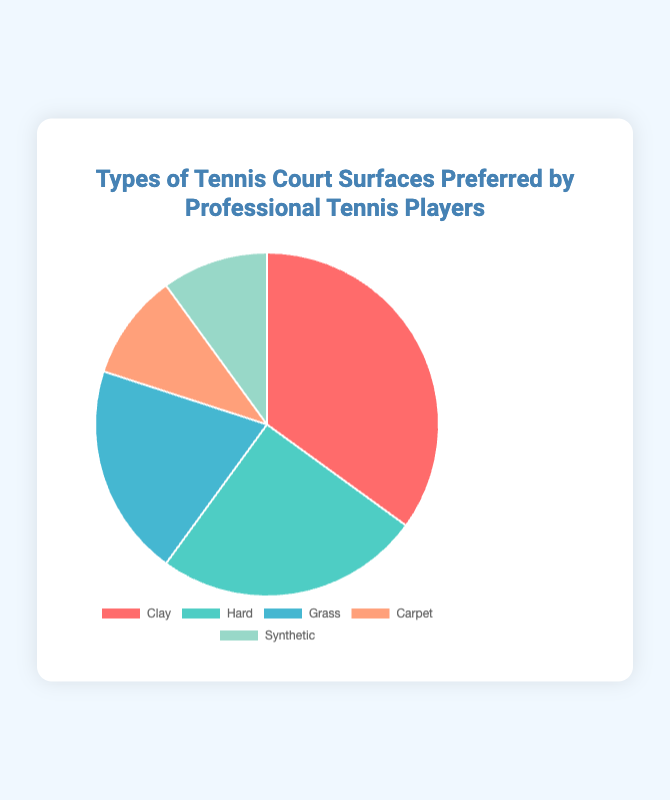What percentage of professional tennis players prefer Grass courts? The "Grass" section of the pie chart shows the percentage of players that prefer Grass courts. According to the data, this percentage is 20%.
Answer: 20% Which type of court surface is most preferred by professional tennis players? The surface with the highest percentage in the pie chart is the most preferred. The "Clay" section of the pie chart has the highest percentage at 35%.
Answer: Clay Which type of court surface is least preferred by professional tennis players? The surfaces with the lowest percentage in the pie chart are the least preferred. The "Carpet" and "Synthetic" sections both have the lowest percentage at 10%.
Answer: Carpet and Synthetic How much more preferred is Clay compared to Hard courts? Subtract the percentage of players who prefer Hard courts (25%) from those who prefer Clay courts (35%). 35% - 25% = 10%.
Answer: 10% more What is the combined preference percentage for Carpet and Synthetic courts? Add the percentage for Carpet (10%) and Synthetic (10%). 10% + 10% = 20%.
Answer: 20% How does the preference for Hard courts compare to Grass courts? The preference for Hard courts is represented by 25% and Grass courts by 20%. Hard courts are 5% more preferred than Grass courts.
Answer: 5% more Which court surface categories share the same preference percentage? The pie chart shows that both "Carpet" and "Synthetic" court surfaces have the same preference percentage of 10%.
Answer: Carpet and Synthetic What is the combined percentage of players who prefer either Clay or Hard courts? Add the percentages of players who prefer Clay (35%) and Hard courts (25%). 35% + 25% = 60%.
Answer: 60% What visual color represents the "Hard" court surface in the chart? The pie chart shows that the "Hard" court surface is represented by a teal color.
Answer: Teal What is the difference in player preference between the most and the least preferred court surfaces? Subtract the preference percentage of the least preferred surfaces (10% for Carpet and Synthetic) from the most preferred surface (35% for Clay). 35% - 10% = 25%.
Answer: 25% 